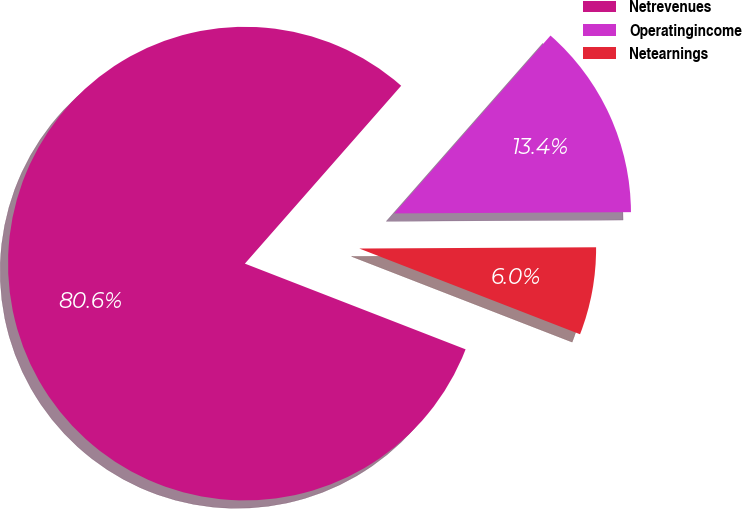Convert chart to OTSL. <chart><loc_0><loc_0><loc_500><loc_500><pie_chart><fcel>Netrevenues<fcel>Operatingincome<fcel>Netearnings<nl><fcel>80.58%<fcel>13.44%<fcel>5.98%<nl></chart> 